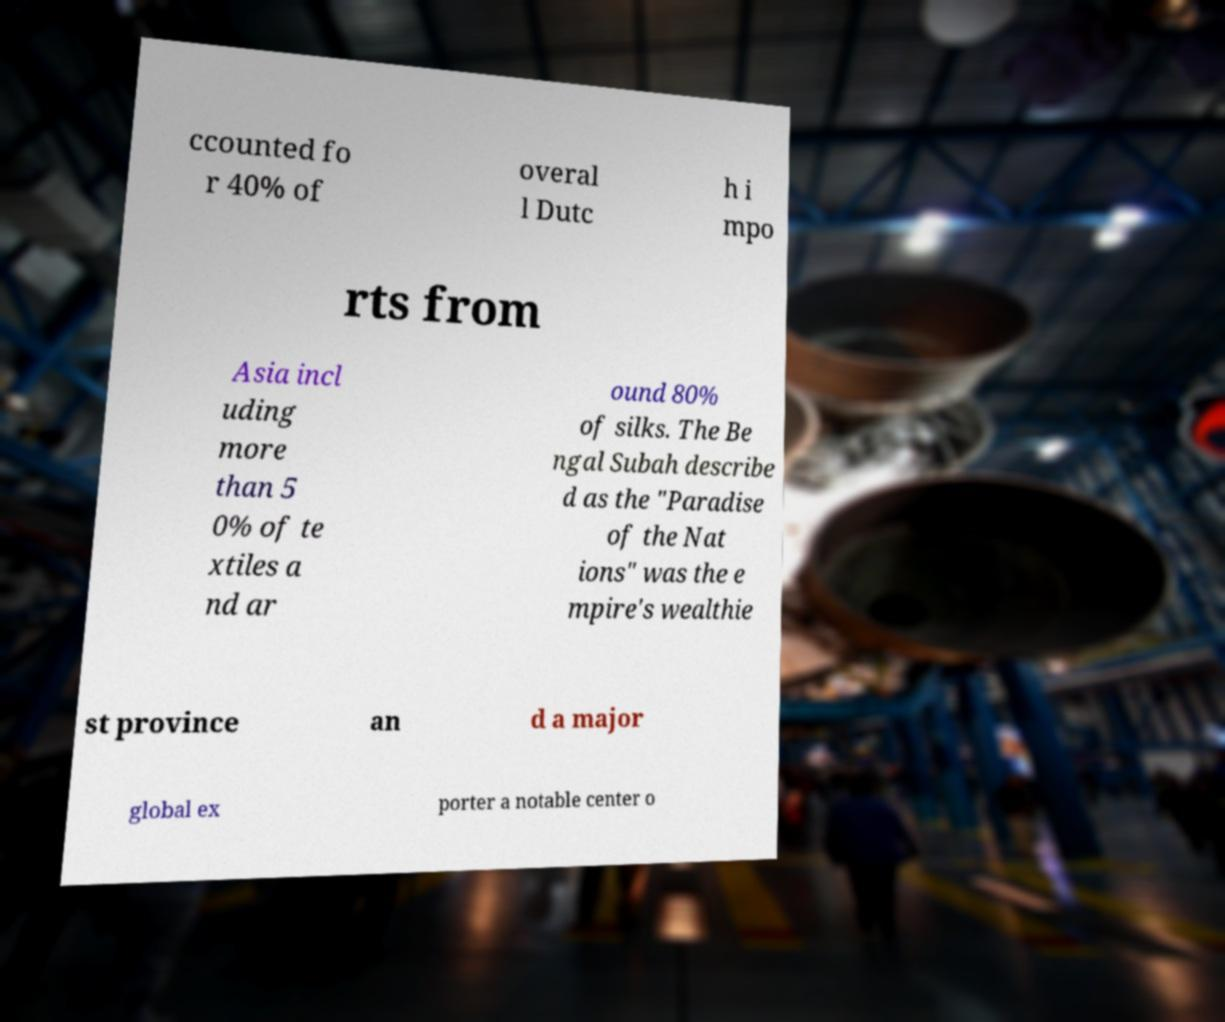There's text embedded in this image that I need extracted. Can you transcribe it verbatim? ccounted fo r 40% of overal l Dutc h i mpo rts from Asia incl uding more than 5 0% of te xtiles a nd ar ound 80% of silks. The Be ngal Subah describe d as the "Paradise of the Nat ions" was the e mpire's wealthie st province an d a major global ex porter a notable center o 